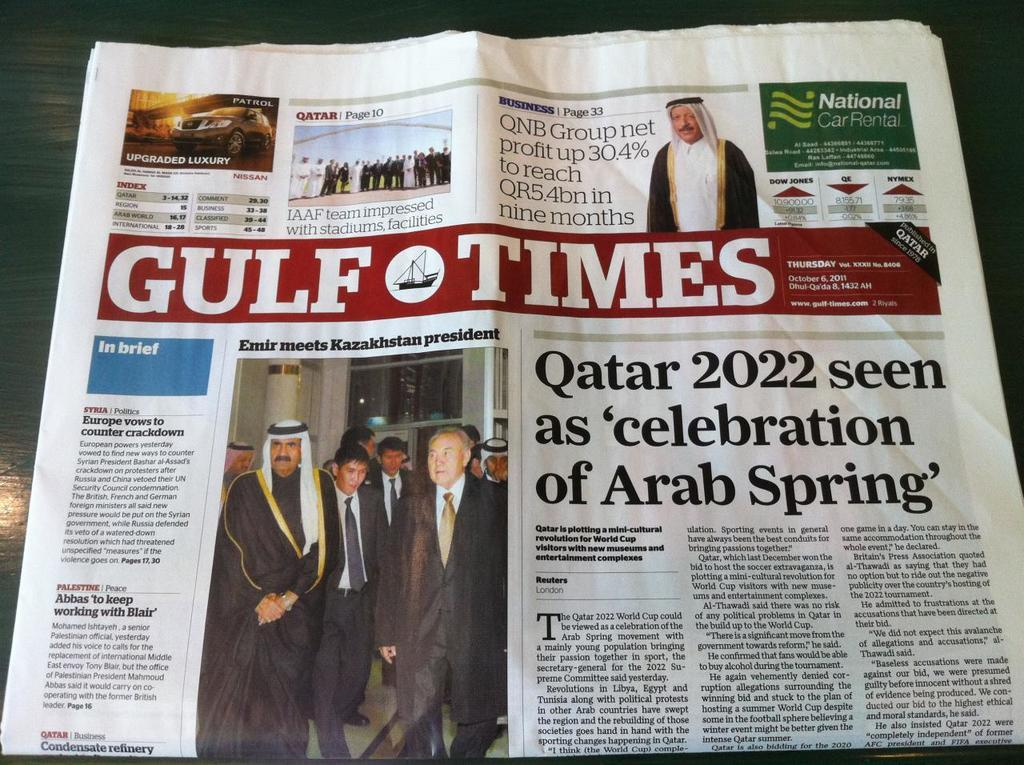What is the main object in the center of the image? There is a newspaper in the center of the image. What might the newspaper be used for? The newspaper might be used for reading news, articles, or other information. Can you describe the appearance of the newspaper? The newspaper appears to be folded and has text and images on its pages. What type of fruit is being negotiated in the agreement mentioned in the newspaper? There is no mention of an agreement or fruit in the image, as it only features a newspaper. 